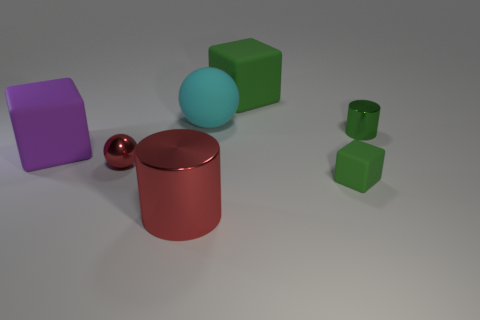Subtract all large green rubber blocks. How many blocks are left? 2 Subtract all blue cylinders. How many green cubes are left? 2 Subtract all purple cubes. How many cubes are left? 2 Add 1 small red metal things. How many objects exist? 8 Subtract all cubes. How many objects are left? 4 Subtract 1 blocks. How many blocks are left? 2 Subtract 0 gray cylinders. How many objects are left? 7 Subtract all brown spheres. Subtract all gray blocks. How many spheres are left? 2 Subtract all big brown things. Subtract all green metallic things. How many objects are left? 6 Add 3 tiny red balls. How many tiny red balls are left? 4 